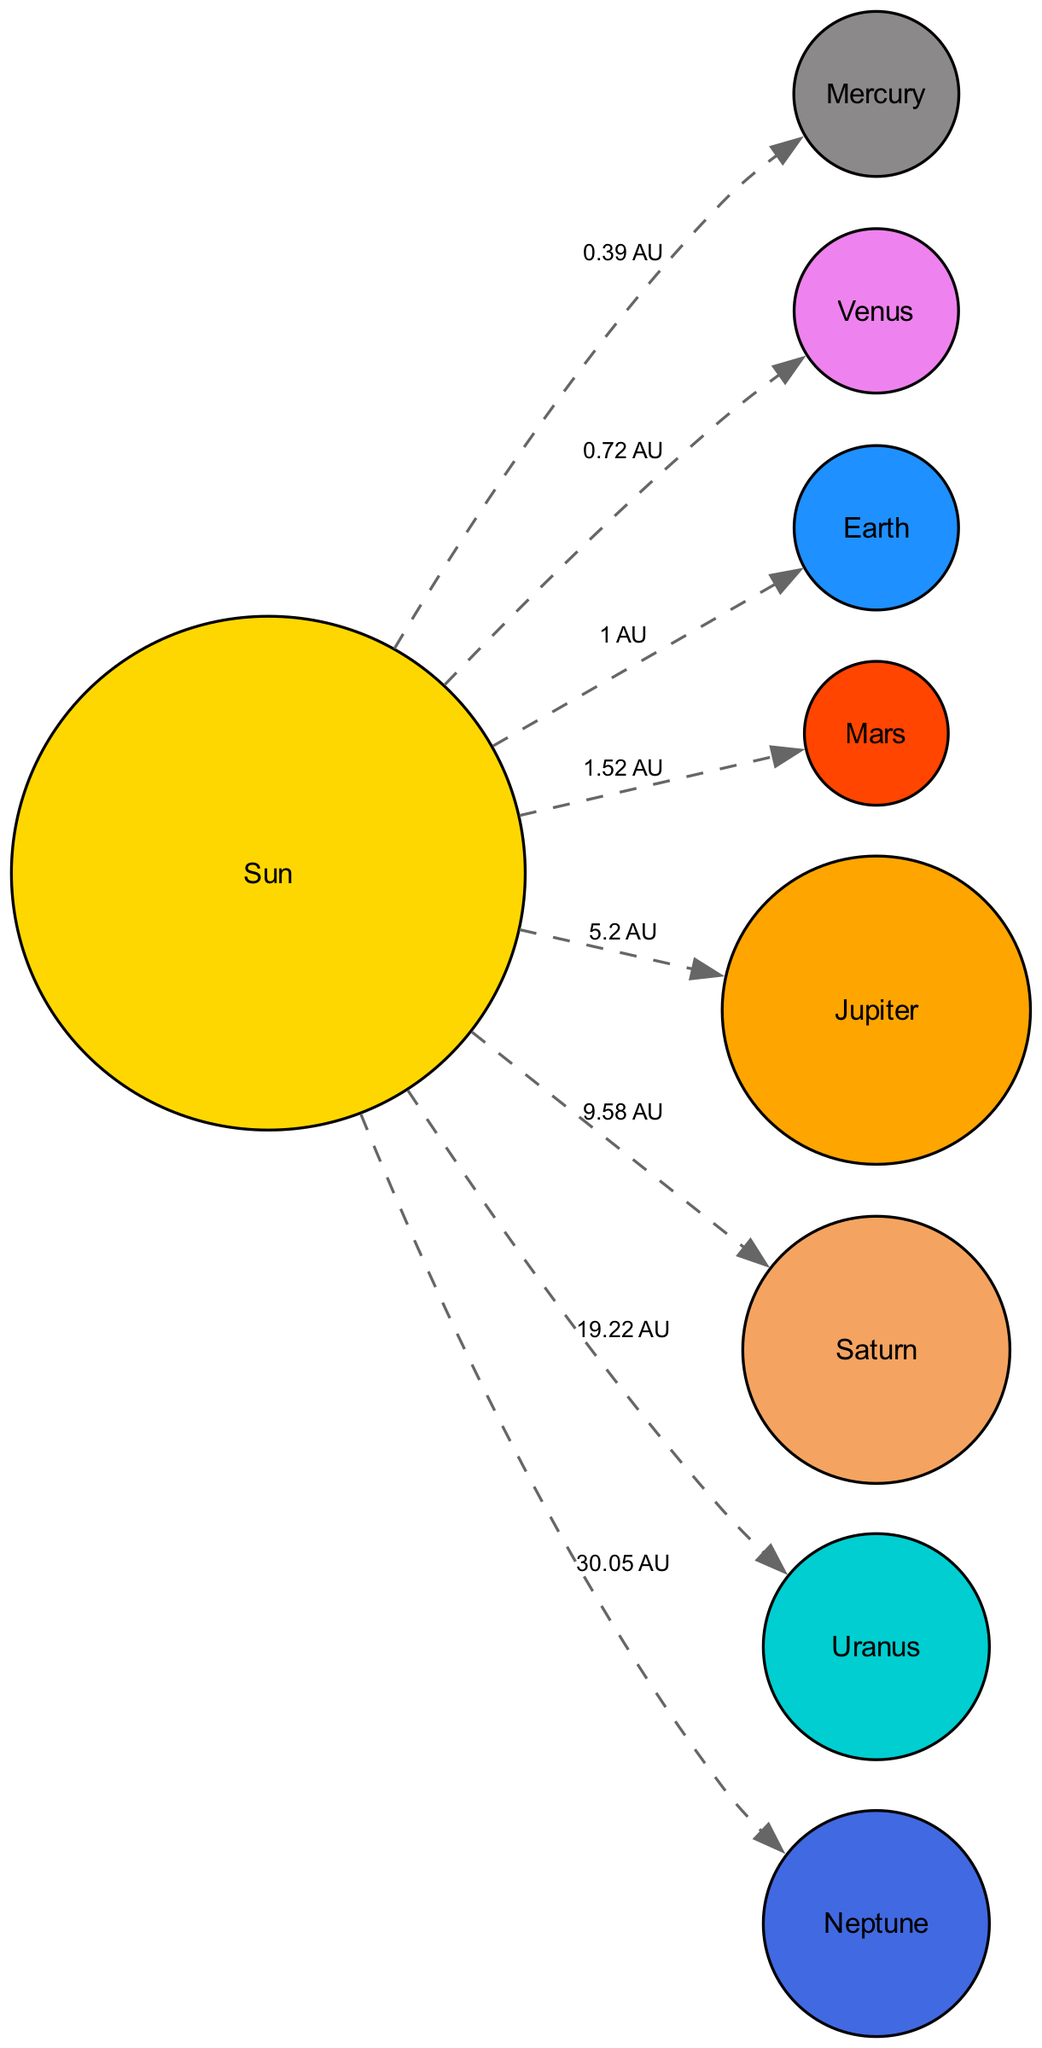What is the distance from the Sun to Mercury? The edge connecting the Sun to Mercury is labeled "0.39 AU", indicating the distance.
Answer: 0.39 AU How many planets are depicted in the diagram? The diagram contains 9 nodes representing the Sun plus 8 planets: Mercury, Venus, Earth, Mars, Jupiter, Saturn, Uranus, and Neptune. Hence, there are 9 planets.
Answer: 9 Which planet is located at 1.52 AU from the Sun? By checking the distances attached to each planet connected to the Sun, Mars connects at 1.52 AU.
Answer: Mars What is the largest planet in the Solar System? The nodes indicate that Jupiter is the largest planet as described in its node.
Answer: Jupiter Which planet has a unique sideways rotation? The description of Uranus specifies its unique sideways rotation, making it the answer.
Answer: Uranus What is the distance from the Sun to Saturn? The edge connecting the Sun and Saturn is labeled "9.58 AU", providing the distance from the Sun.
Answer: 9.58 AU Which two planets have orbits closer together than the orbit of Earth? Checking the distances and connections, Mercury (0.39 AU) and Venus (0.72 AU) are closer to the Sun than Earth (1 AU).
Answer: Mercury and Venus Which planet is known for its prominent ring system? The node for Saturn directly describes it as famous for its prominent ring system, identifying it.
Answer: Saturn What is the distance from the Sun to Neptune? The edge leading from the Sun to Neptune shows the distance labeled as "30.05 AU", indicating the measurement.
Answer: 30.05 AU 